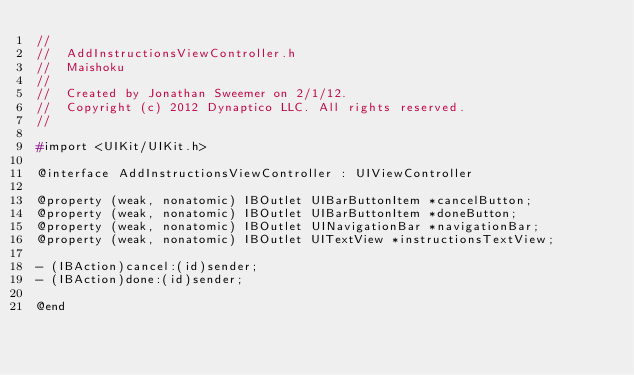<code> <loc_0><loc_0><loc_500><loc_500><_C_>//
//  AddInstructionsViewController.h
//  Maishoku
//
//  Created by Jonathan Sweemer on 2/1/12.
//  Copyright (c) 2012 Dynaptico LLC. All rights reserved.
//

#import <UIKit/UIKit.h>

@interface AddInstructionsViewController : UIViewController

@property (weak, nonatomic) IBOutlet UIBarButtonItem *cancelButton;
@property (weak, nonatomic) IBOutlet UIBarButtonItem *doneButton;
@property (weak, nonatomic) IBOutlet UINavigationBar *navigationBar;
@property (weak, nonatomic) IBOutlet UITextView *instructionsTextView;

- (IBAction)cancel:(id)sender;
- (IBAction)done:(id)sender;

@end
</code> 